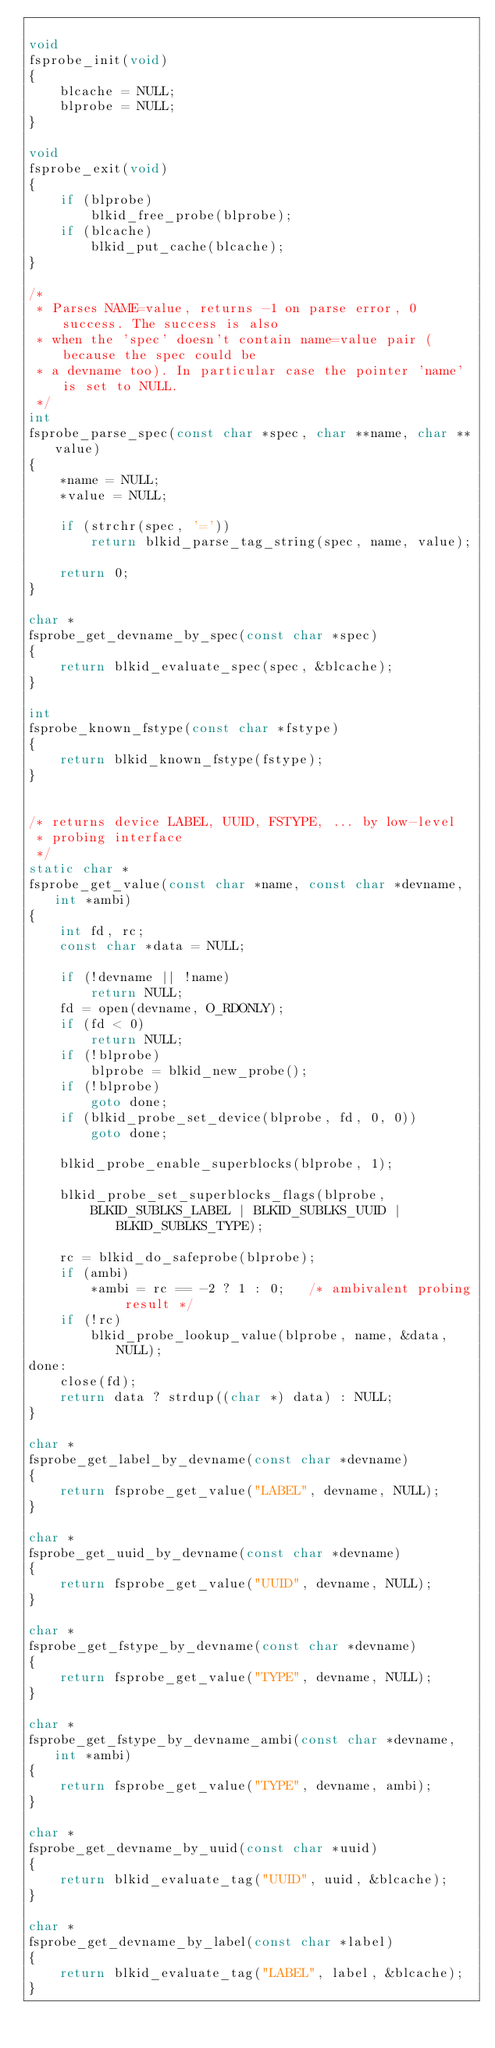<code> <loc_0><loc_0><loc_500><loc_500><_C_>
void
fsprobe_init(void)
{
	blcache = NULL;
	blprobe = NULL;
}

void
fsprobe_exit(void)
{
	if (blprobe)
		blkid_free_probe(blprobe);
	if (blcache)
		blkid_put_cache(blcache);
}

/*
 * Parses NAME=value, returns -1 on parse error, 0 success. The success is also
 * when the 'spec' doesn't contain name=value pair (because the spec could be
 * a devname too). In particular case the pointer 'name' is set to NULL.
 */
int
fsprobe_parse_spec(const char *spec, char **name, char **value)
{
	*name = NULL;
	*value = NULL;

	if (strchr(spec, '='))
		return blkid_parse_tag_string(spec, name, value);

	return 0;
}

char *
fsprobe_get_devname_by_spec(const char *spec)
{
	return blkid_evaluate_spec(spec, &blcache);
}

int
fsprobe_known_fstype(const char *fstype)
{
	return blkid_known_fstype(fstype);
}


/* returns device LABEL, UUID, FSTYPE, ... by low-level
 * probing interface
 */
static char *
fsprobe_get_value(const char *name, const char *devname, int *ambi)
{
	int fd, rc;
	const char *data = NULL;

	if (!devname || !name)
		return NULL;
	fd = open(devname, O_RDONLY);
	if (fd < 0)
		return NULL;
	if (!blprobe)
		blprobe = blkid_new_probe();
	if (!blprobe)
		goto done;
	if (blkid_probe_set_device(blprobe, fd, 0, 0))
		goto done;

	blkid_probe_enable_superblocks(blprobe, 1);

	blkid_probe_set_superblocks_flags(blprobe,
		BLKID_SUBLKS_LABEL | BLKID_SUBLKS_UUID | BLKID_SUBLKS_TYPE);

	rc = blkid_do_safeprobe(blprobe);
	if (ambi)
		*ambi = rc == -2 ? 1 : 0;	/* ambivalent probing result */
	if (!rc)
		blkid_probe_lookup_value(blprobe, name, &data, NULL);
done:
	close(fd);
	return data ? strdup((char *) data) : NULL;
}

char *
fsprobe_get_label_by_devname(const char *devname)
{
	return fsprobe_get_value("LABEL", devname, NULL);
}

char *
fsprobe_get_uuid_by_devname(const char *devname)
{
	return fsprobe_get_value("UUID", devname, NULL);
}

char *
fsprobe_get_fstype_by_devname(const char *devname)
{
	return fsprobe_get_value("TYPE", devname, NULL);
}

char *
fsprobe_get_fstype_by_devname_ambi(const char *devname, int *ambi)
{
	return fsprobe_get_value("TYPE", devname, ambi);
}

char *
fsprobe_get_devname_by_uuid(const char *uuid)
{
	return blkid_evaluate_tag("UUID", uuid, &blcache);
}

char *
fsprobe_get_devname_by_label(const char *label)
{
	return blkid_evaluate_tag("LABEL", label, &blcache);
}

</code> 